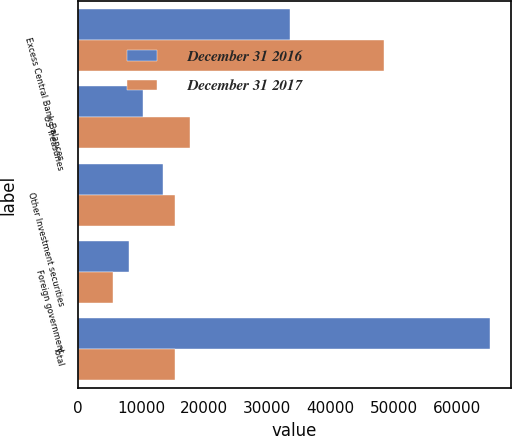Convert chart to OTSL. <chart><loc_0><loc_0><loc_500><loc_500><stacked_bar_chart><ecel><fcel>Excess Central Bank Balances<fcel>US Treasuries<fcel>Other Investment securities<fcel>Foreign government<fcel>Total<nl><fcel>December 31 2016<fcel>33584<fcel>10278<fcel>13422<fcel>8064<fcel>65348<nl><fcel>December 31 2017<fcel>48407<fcel>17770<fcel>15442<fcel>5585<fcel>15442<nl></chart> 